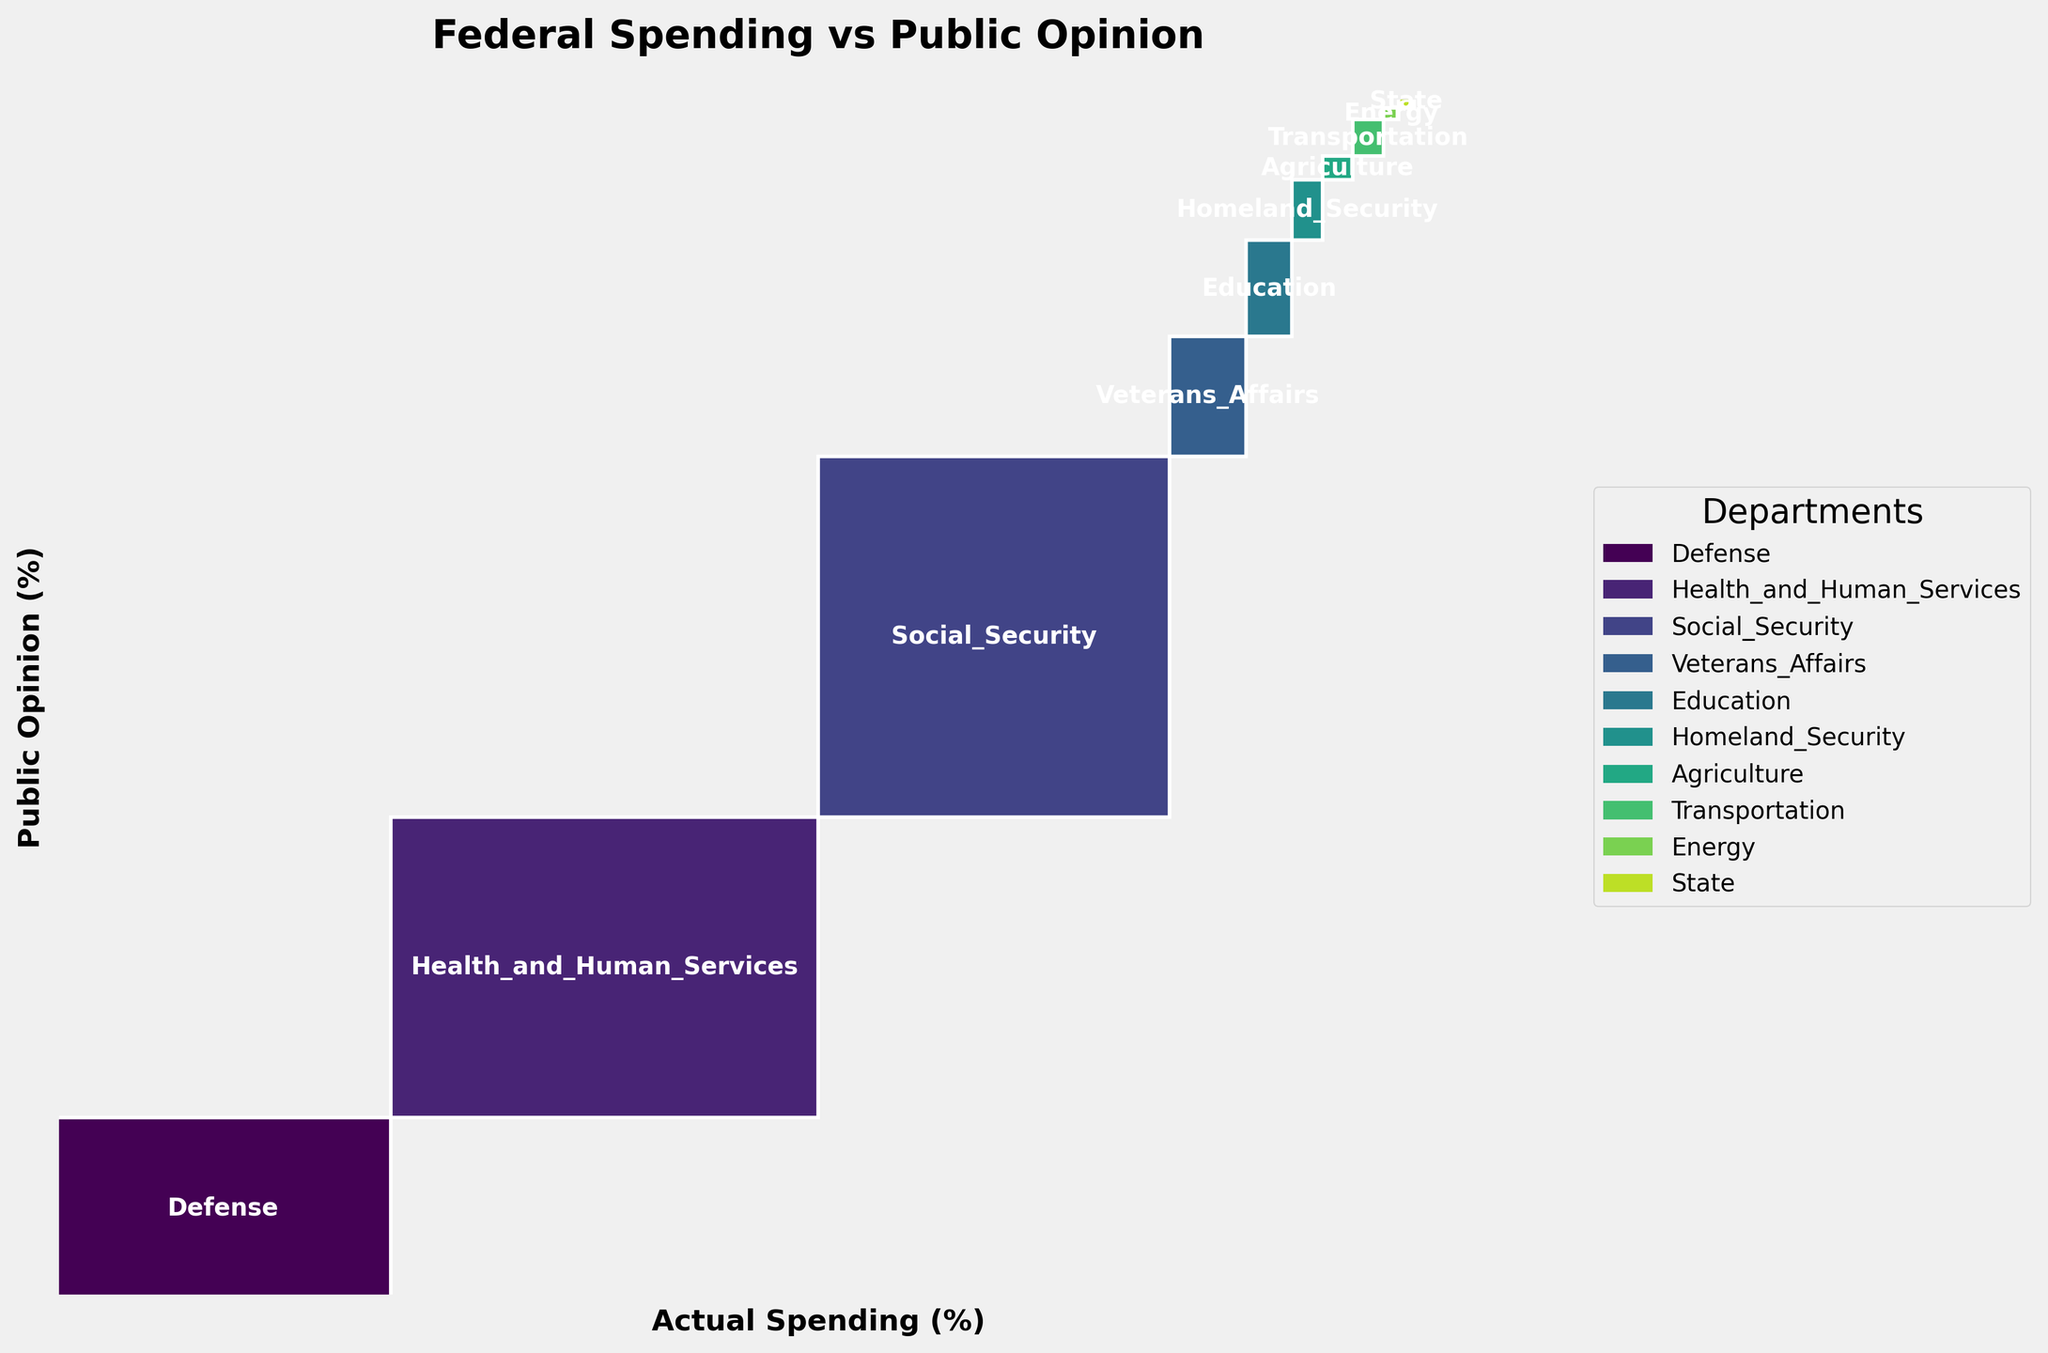What is the title of the plot? The title is found at the top of the figure, displaying the overall theme or main subject of the plot. It is often in a larger or bold font to stand out.
Answer: Federal Spending vs Public Opinion How many government departments are compared in the plot? Count the names of departments listed in the plot's legend or directly on the plot. Each department is represented by a unique color and label.
Answer: 10 Which government department has the largest discrepancy between actual spending and public opinion? Identify the department with the most significant difference between its actual spending and public opinion rectangle sizes. This requires observing the width (actual spending) and height (public opinion) of each department's rectangle.
Answer: Defense What is the cumulative actual spending percentage for Health and Human Services, Social Security, and Defense? Sum the actual spending percentages of the specified departments. Actual spending for Health and Human Services is 28, Social Security is 23, and Defense is 22. 28 + 23 + 22 = 73.
Answer: 73% Which department's actual spending percentage aligns most closely with the public opinion percentage? Compare the height and width of each department’s rectangle. Look for the department where the rectangle's dimensions (actual spending and public opinion) are most similar.
Answer: Agriculture Is the actual spending on Veterans Affairs more or less than the public opinion? And by how much? Compare the width (actual spending) and height (public opinion) of the Veterans Affairs rectangle. The actual spending is 5%, and public opinion is 10%. The difference is 10 - 5 = 5.
Answer: Less by 5% What is the total of public opinion percentages for all departments combined? Sum all public opinion percentages provided for each department. Public Opinion percentages: 15 + 25 + 30 + 10 + 8 + 5 + 2 + 3 + 1 + 1 = 100.
Answer: 100% Which department is represented by the largest rectangle in terms of area (width * height)? Calculate the area for each department by multiplying the width (actual spending) by the height (public opinion). The department with the largest resulting product has the largest rectangle.
Answer: Health and Human Services How do the public opinions on Education and Homeland Security compare to their actual spending? Compare the height (public opinion) to the width (actual spending) for these departments. Education: 3% actual vs. 8% public opinion. Homeland Security: 2% actual vs. 5% public opinion. In both cases, public opinion is higher.
Answer: Both have higher public opinion 